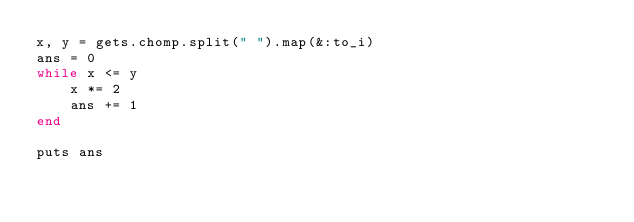<code> <loc_0><loc_0><loc_500><loc_500><_Ruby_>x, y = gets.chomp.split(" ").map(&:to_i)
ans = 0
while x <= y
    x *= 2
    ans += 1
end

puts ans</code> 